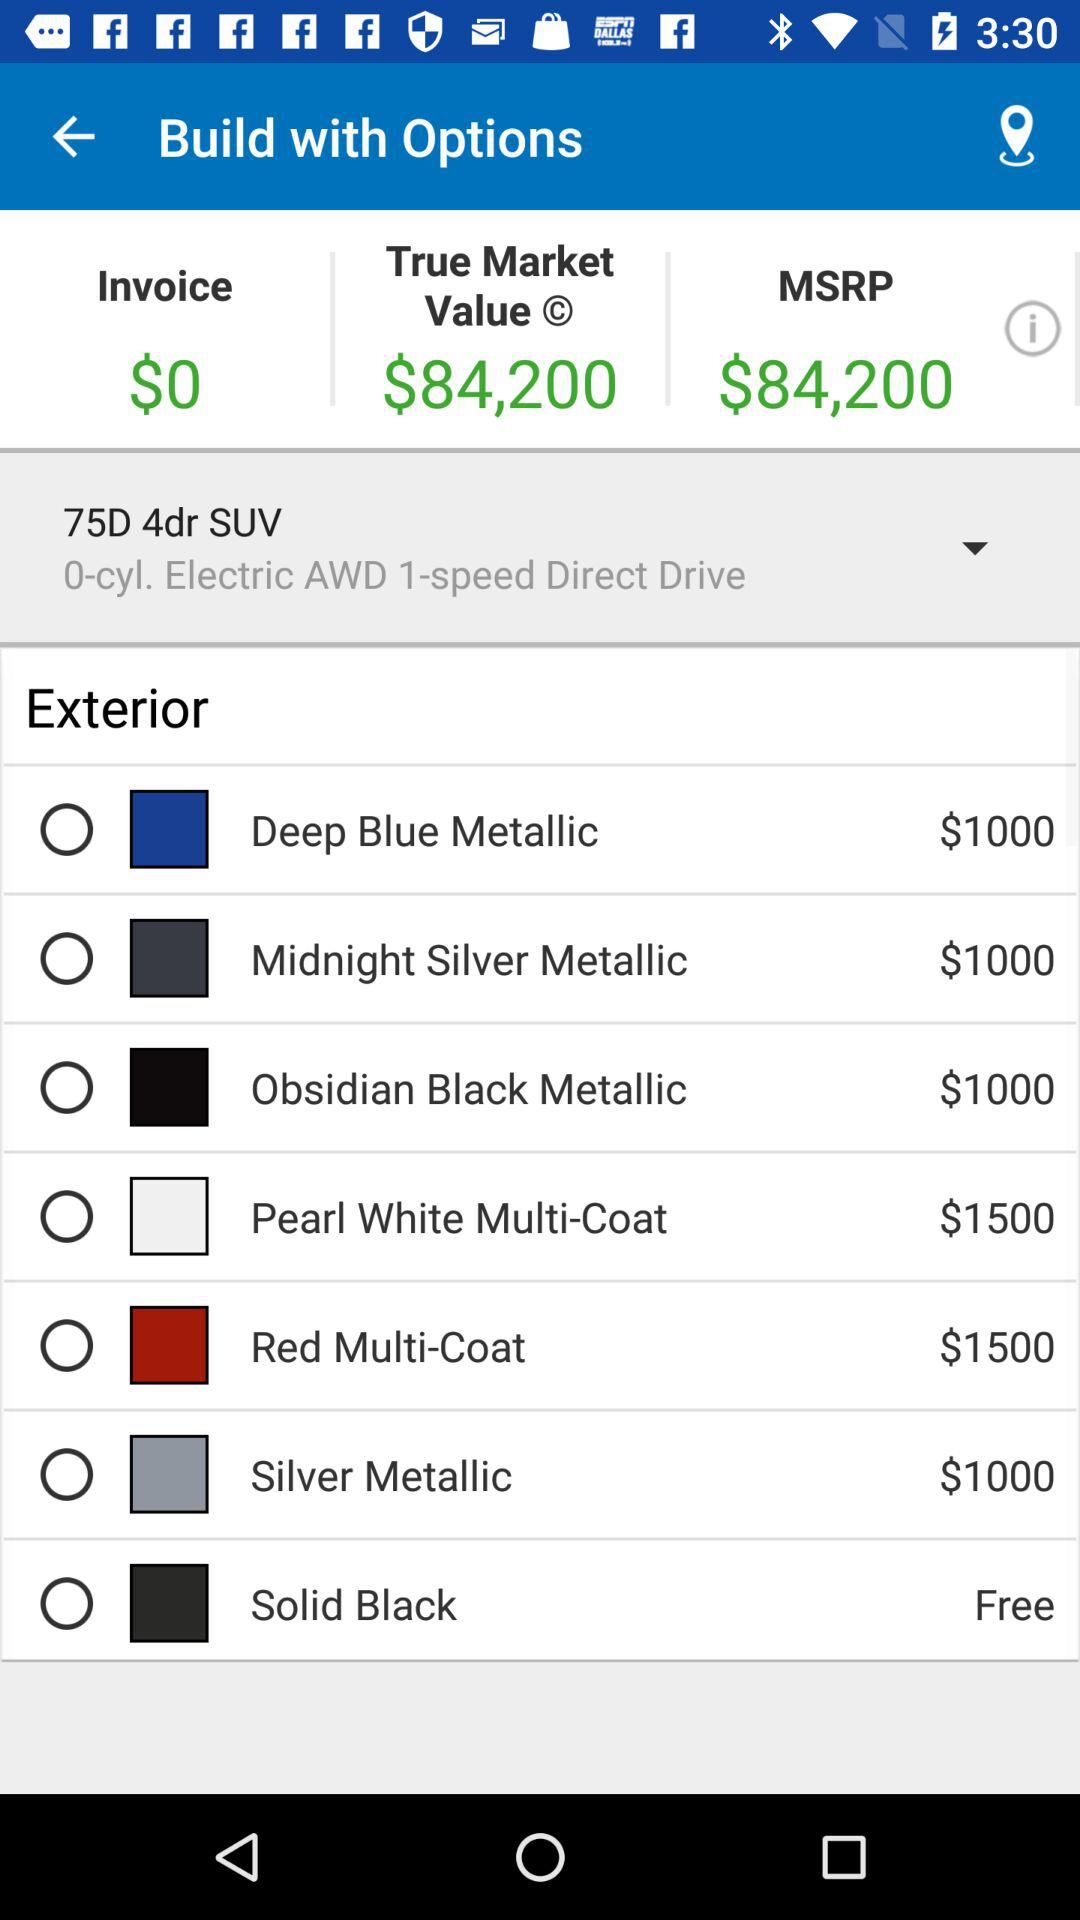How much does the silver metallic cost? The silver metallic costs $1000. 